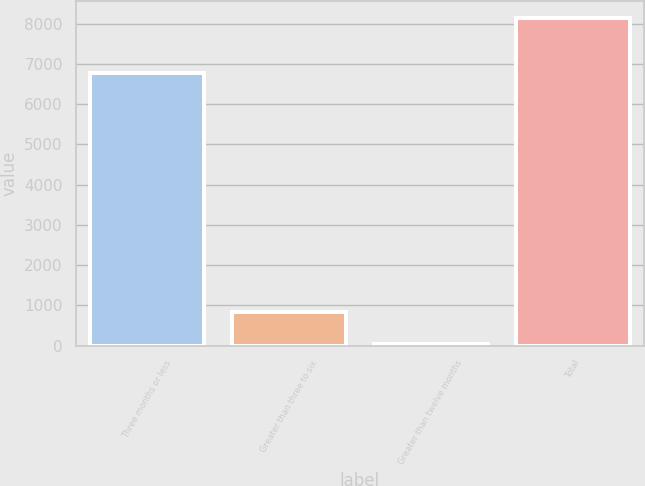Convert chart to OTSL. <chart><loc_0><loc_0><loc_500><loc_500><bar_chart><fcel>Three months or less<fcel>Greater than three to six<fcel>Greater than twelve months<fcel>Total<nl><fcel>6779<fcel>848.4<fcel>38<fcel>8142<nl></chart> 